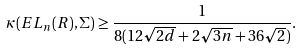<formula> <loc_0><loc_0><loc_500><loc_500>\kappa ( E L _ { n } ( R ) , \Sigma ) \geq \frac { 1 } { 8 ( 1 2 \sqrt { 2 d } + 2 \sqrt { 3 n } + 3 6 \sqrt { 2 } ) } .</formula> 